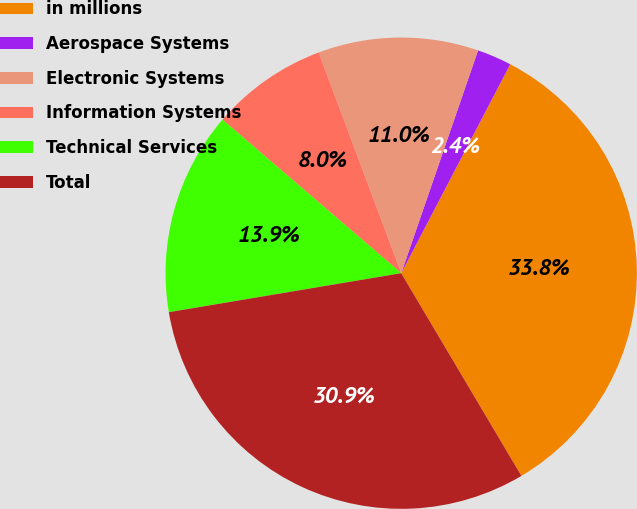Convert chart. <chart><loc_0><loc_0><loc_500><loc_500><pie_chart><fcel>in millions<fcel>Aerospace Systems<fcel>Electronic Systems<fcel>Information Systems<fcel>Technical Services<fcel>Total<nl><fcel>33.83%<fcel>2.37%<fcel>10.98%<fcel>8.01%<fcel>13.94%<fcel>30.87%<nl></chart> 